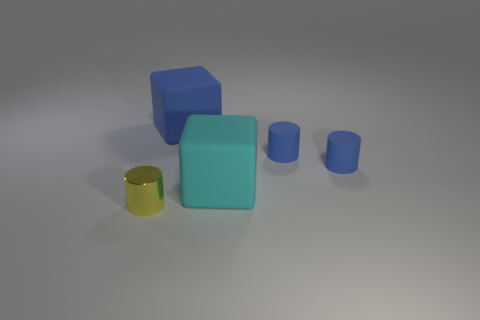Which objects in the image could serve as containers? In the image, the gold cylinder seems to have an open top and likely could serve as a container. The blue cubes and the cyan rubber object appear to be solid and would not function as containers. 